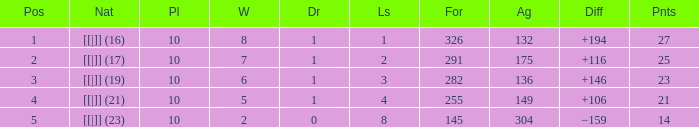 How many table points are listed for the deficit is +194?  1.0. 